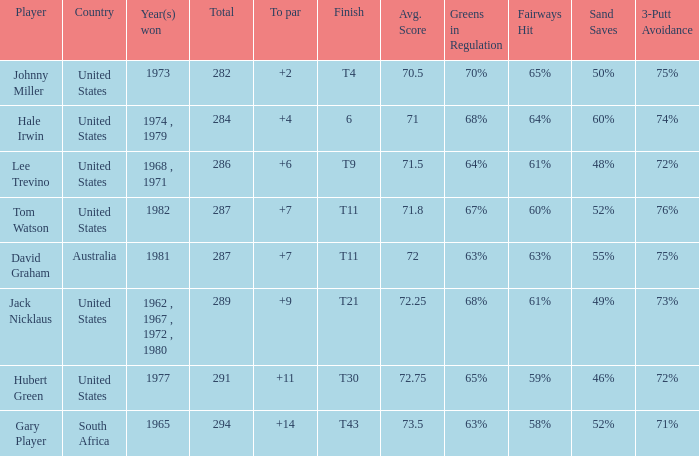WHAT IS THE TOTAL, OF A TO PAR FOR HUBERT GREEN, AND A TOTAL LARGER THAN 291? 0.0. 